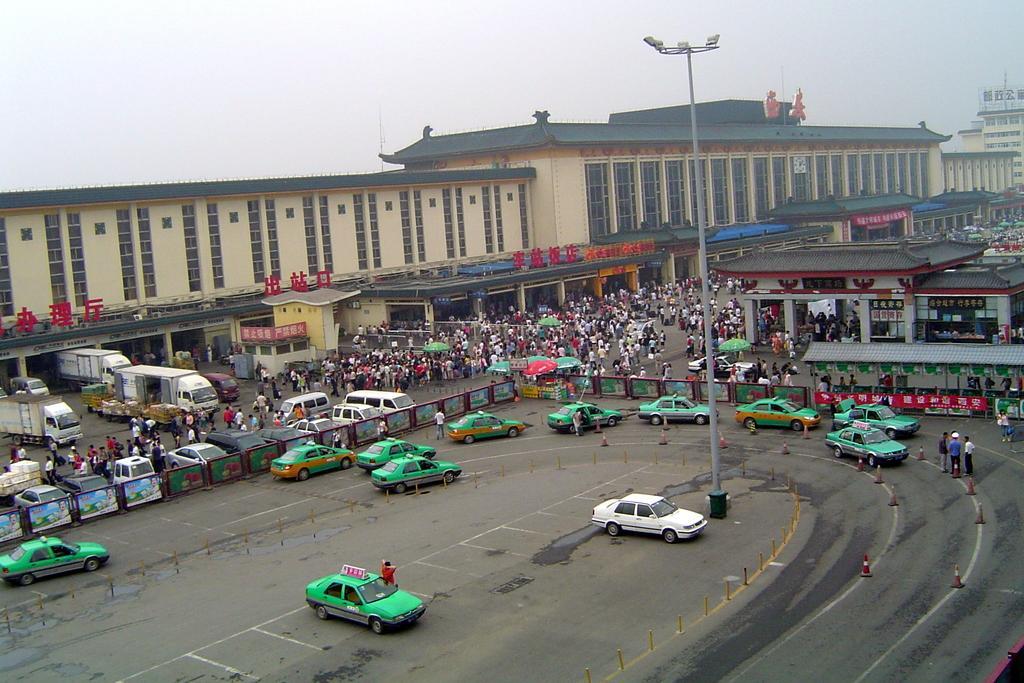Can you describe this image briefly? In this picture I can see the roads on which there are number of cars, people and number of boards. I can also see the traffic cones. In the center of this picture I can see a light pole. In the background I can see number of buildings and the sky. 